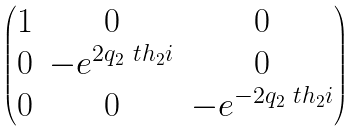Convert formula to latex. <formula><loc_0><loc_0><loc_500><loc_500>\begin{pmatrix} 1 & 0 & 0 \\ 0 & - e ^ { 2 q _ { 2 } \ t h _ { 2 } i } & 0 \\ 0 & 0 & - e ^ { - 2 q _ { 2 } \ t h _ { 2 } i } \\ \end{pmatrix}</formula> 